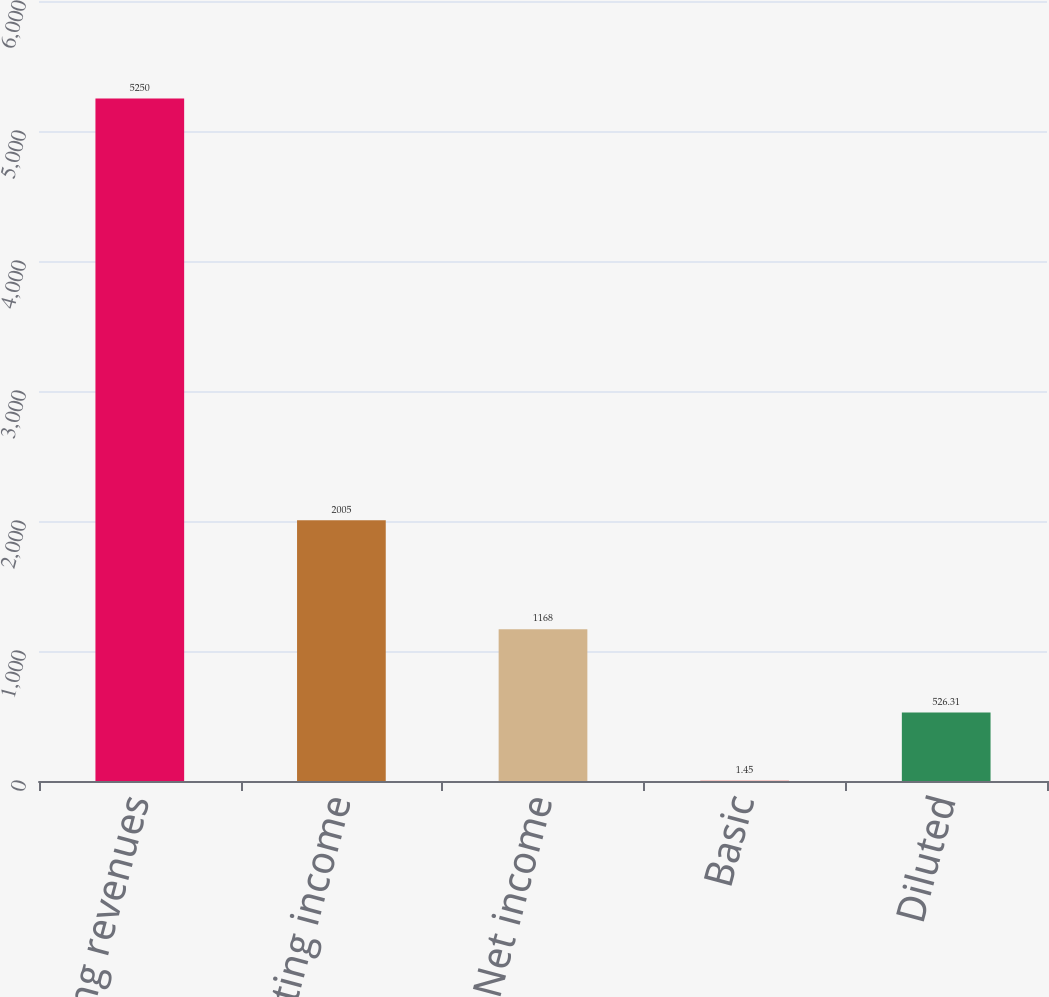<chart> <loc_0><loc_0><loc_500><loc_500><bar_chart><fcel>Operating revenues<fcel>Operating income<fcel>Net income<fcel>Basic<fcel>Diluted<nl><fcel>5250<fcel>2005<fcel>1168<fcel>1.45<fcel>526.31<nl></chart> 